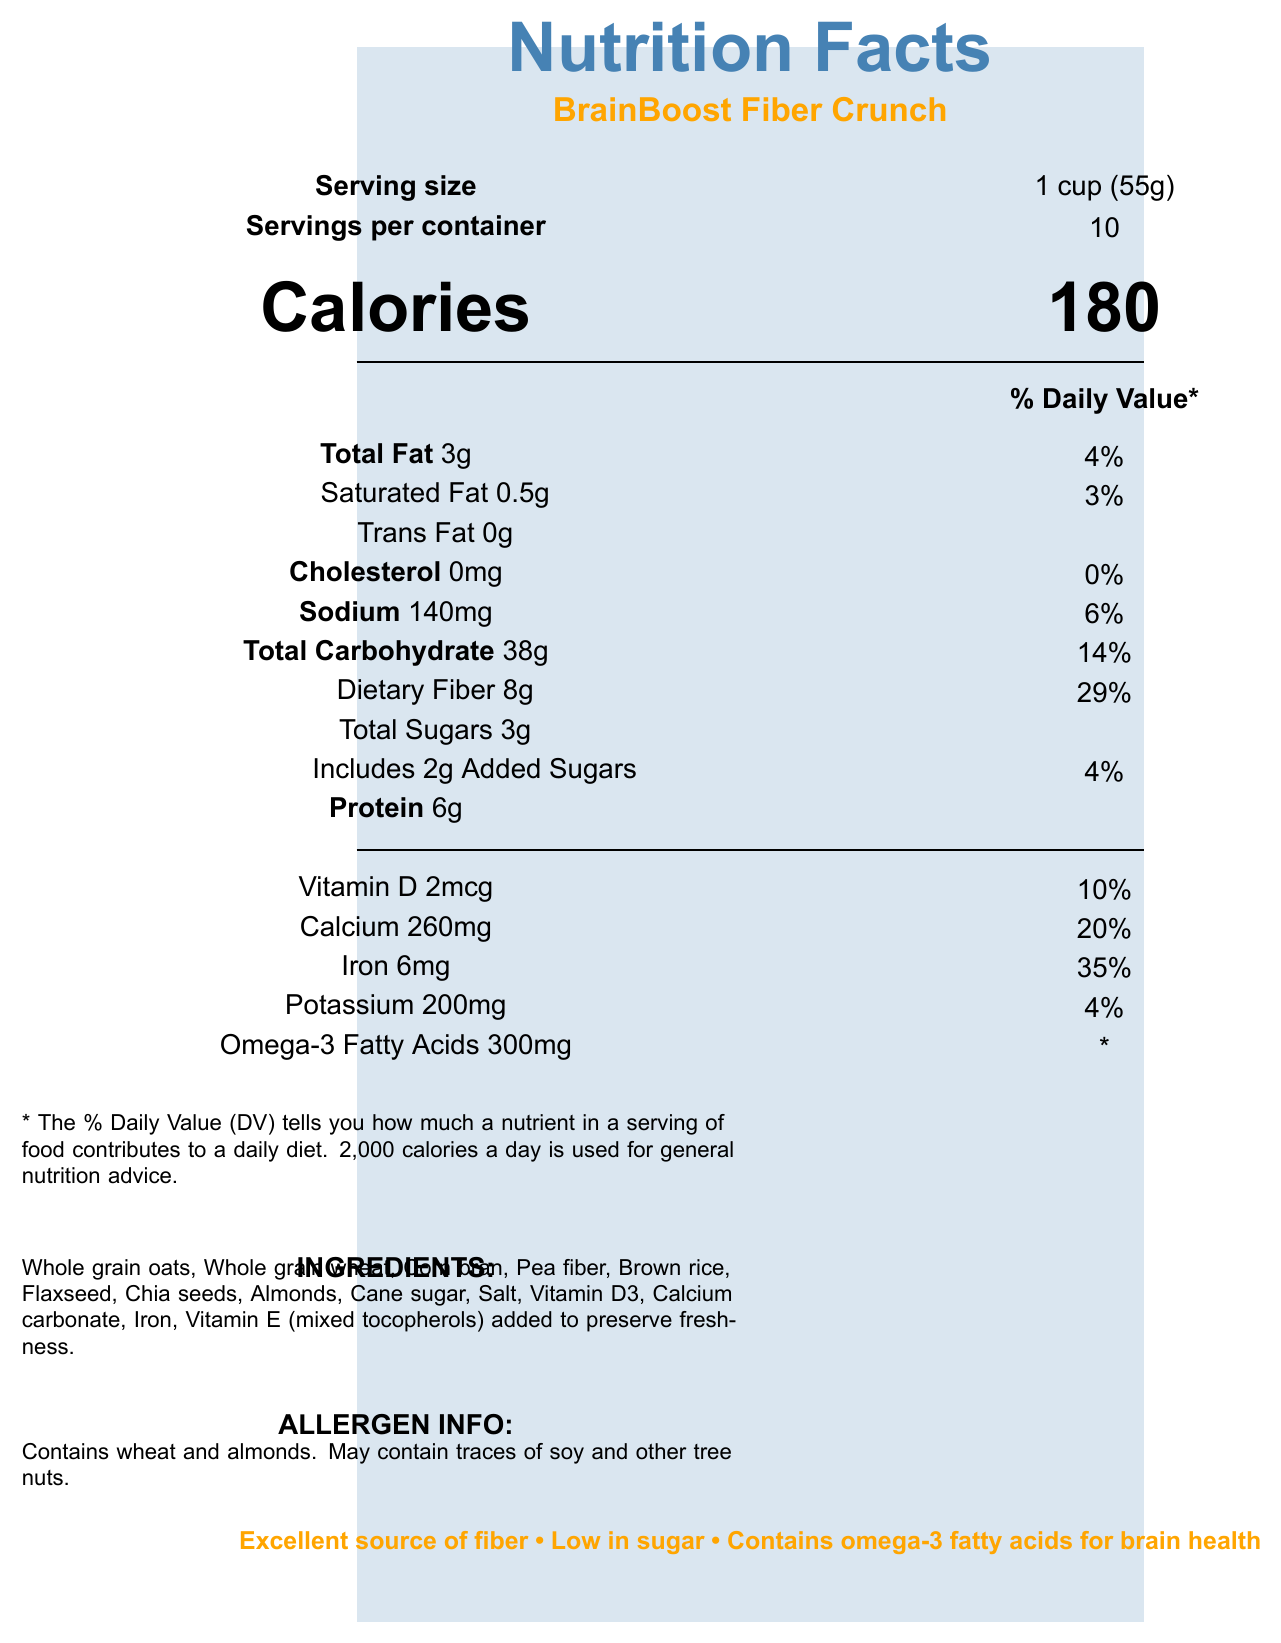what is the serving size? The serving size is mentioned in the document as "1 cup (55g)".
Answer: 1 cup (55g) how many calories are there per serving? The document states that there are 180 calories per serving.
Answer: 180 what is the total fat content and its daily value percentage per serving? The document mentions "Total Fat 3g" with a daily value percentage of "4%".
Answer: 3g, 4% are there any trans fats in this cereal? The document indicates that there are "0g" of trans fat.
Answer: No how much dietary fiber is in one serving? The document specifies that the dietary fiber content per serving is "8g".
Answer: 8g what is the daily value percentage of iron in this cereal? The daily value for iron given in the document is "35%".
Answer: 35% does this cereal contain any cholesterol? The document mentions "Cholesterol 0mg" which means it does not contain any cholesterol.
Answer: No what health benefits does the cereal claim to provide? The health claims listed include being an excellent source of fiber, low in sugar, containing omega-3 fatty acids for brain health, being a good source of iron, and having calcium and vitamin D for strong bones.
Answer: Excellent source of fiber, Low in sugar, Contains omega-3 fatty acids for brain health, Good source of iron for energy and focus, Calcium and vitamin D for strong bones what is a notable source of fat in this cereal? A. Olive oil B. Flaxseed C. Butter D. Palm oil The document lists flaxseed as one of the ingredients which is known to be a source of polyunsaturated and omega-3 fatty acids.
Answer: B. Flaxseed which of the following nutrients doesn't have a percentage daily value provided? A. Omega-3 Fatty Acids B. Sodium C. Calcium D. Vitamin D The daily value for omega-3 fatty acids is marked with an asterisk (*) indicating that there's no established daily value.
Answer: A. Omega-3 Fatty Acids does the cereal contain added sugars? The document states that the cereal includes "2g Added Sugars".
Answer: Yes how many servings are in a container of this cereal? The document notes that there are "10" servings per container.
Answer: 10 is this cereal allergen-free? The document specifies that the cereal contains wheat and almonds and may contain traces of soy and other tree nuts.
Answer: No who is this cereal recommended for? The additional information states that the cereal is perfect for active teens building strength and confidence.
Answer: Active teens building strength and confidence is this cereal suitable for someone allergic to wheat? The allergen info in the document mentions that it contains wheat.
Answer: No how many grams of total sugars are in one serving of cereal? The document lists "Total Sugars 3g" for one serving.
Answer: 3g what is the main purpose of the document? The document serves to inform readers about the nutritional content, ingredients, health claims, and allergen information of BrainBoost Fiber Crunch cereal.
Answer: To provide nutritional information about BrainBoost Fiber Crunch cereal. how much polyunsaturated fat is in one serving? The document states that there are "1.5g" of polyunsaturated fat per serving.
Answer: 1.5g what is the source of vitamin E in this cereal? The document lists "Vitamin E (mixed tocopherols) added to preserve freshness" in the ingredients section.
Answer: Mixed tocopherols added to preserve freshness what is the amount of calcium in one serving? The document indicates that each serving contains "260mg" of calcium.
Answer: 260mg where is the cereal manufactured? The document does not provide any information regarding the manufacturing location of the cereal.
Answer: Not enough information 